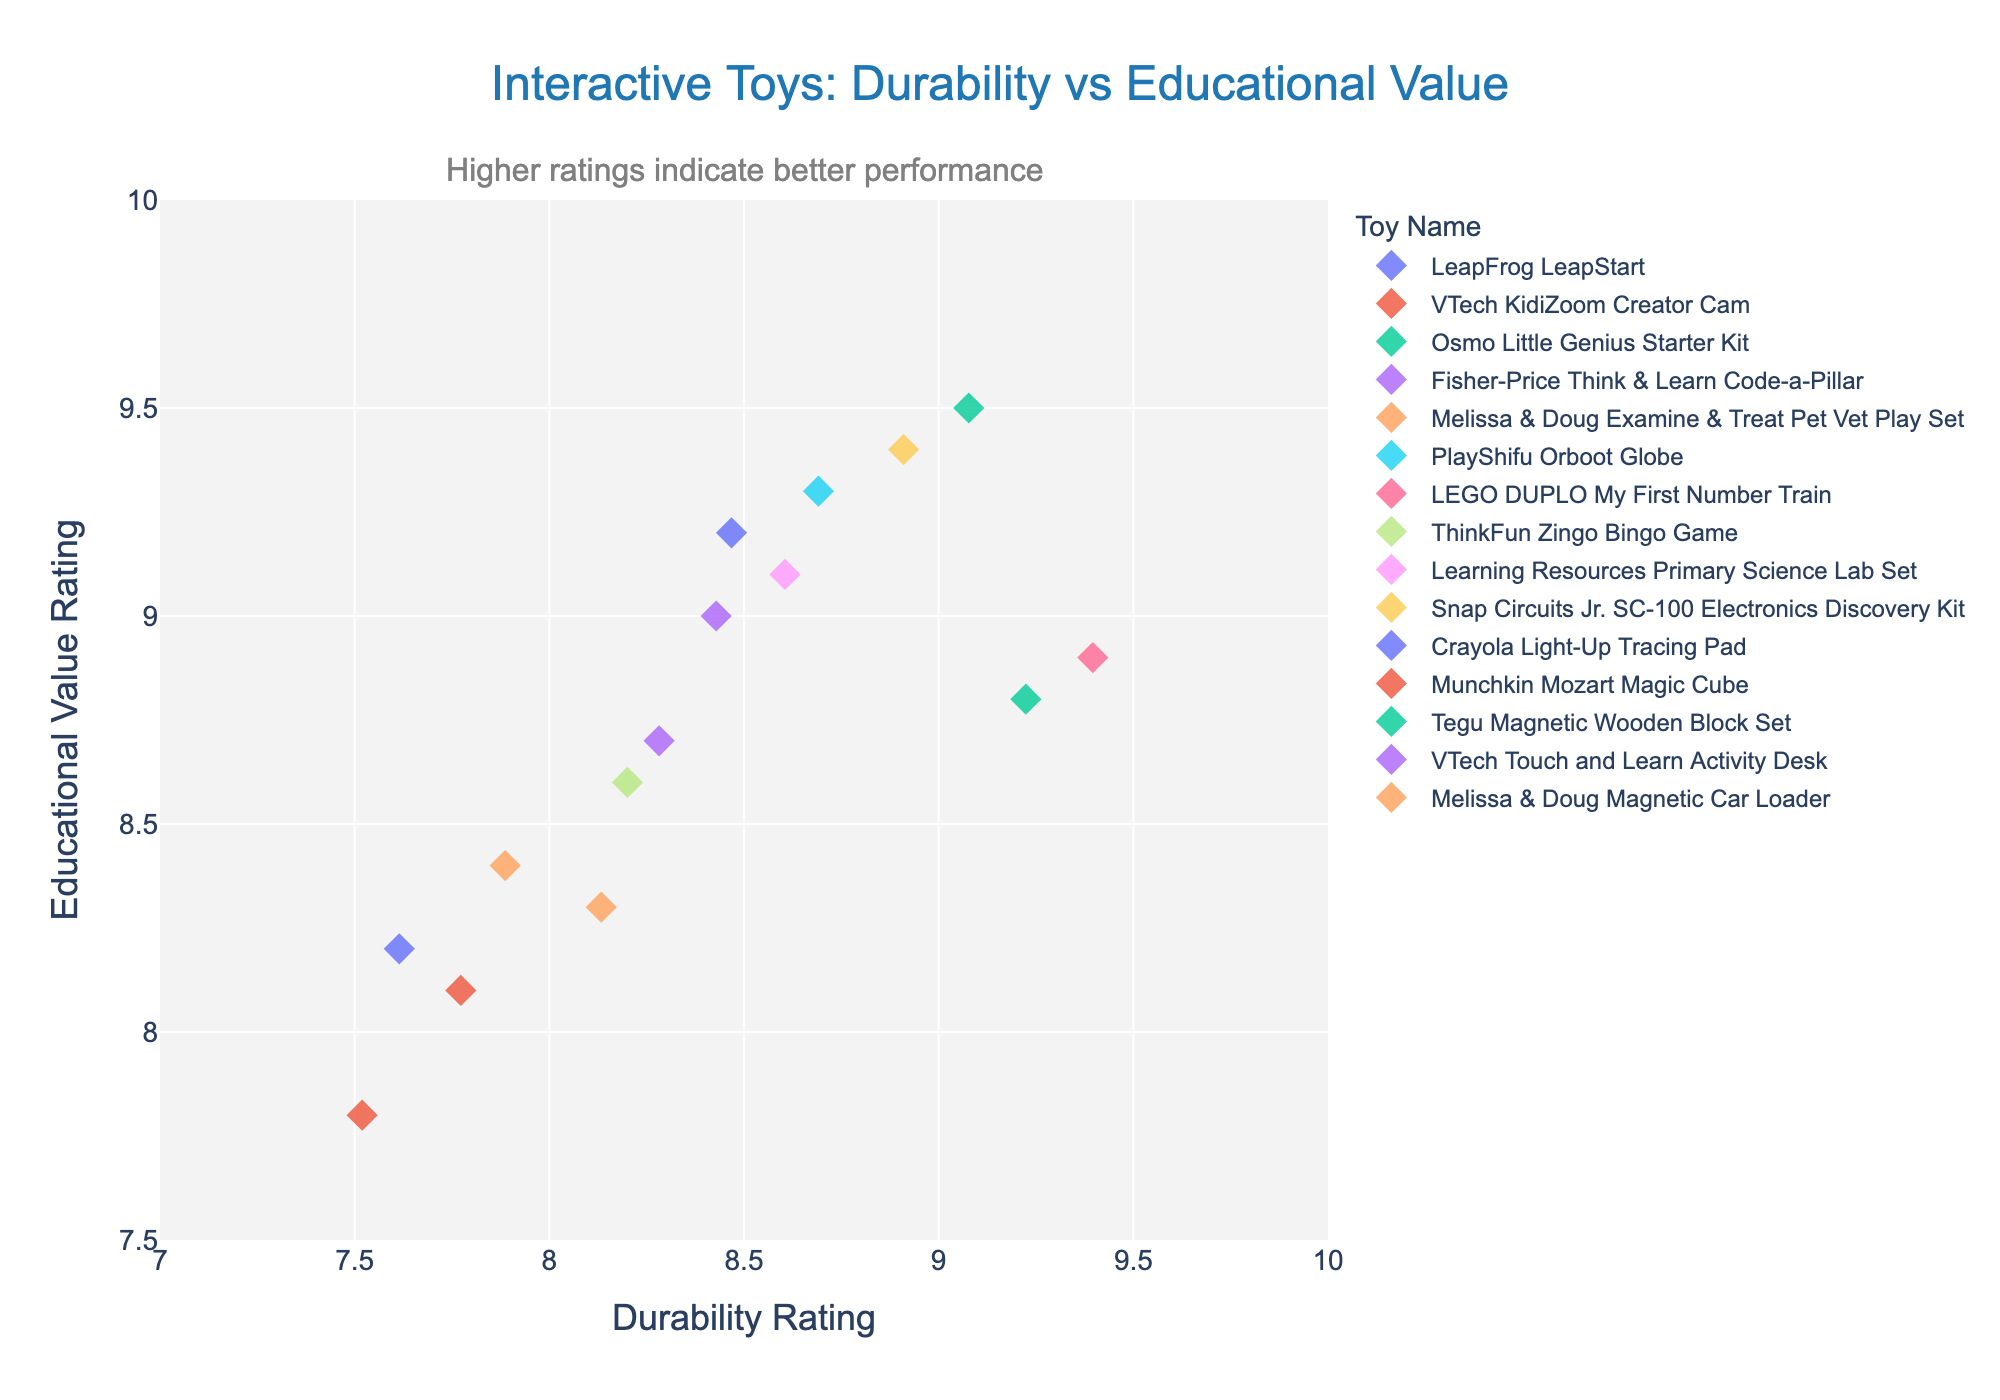What is the title of the plot? The title is displayed at the top of the plot in larger, bolded text, making it readily visible.
Answer: Interactive Toys: Durability vs Educational Value How many toys are shown in the plot? Each strip point corresponds to one toy, and there are markers with different colors, each representing a unique toy name. By counting these, we see there are 15 toys.
Answer: 15 Which toy has the highest durability rating? Look at the x-axis labeled "Durability Rating" and find the point farthest to the right. The toy at this point is "LEGO DUPLO My First Number Train" with a rating of 9.4.
Answer: LEGO DUPLO My First Number Train Which toy has the lowest educational value rating? Look at the y-axis labeled "Educational Value Rating" and find the point lowest on the axis. The toy at this point is "Munchkin Mozart Magic Cube" with a rating of 7.8.
Answer: Munchkin Mozart Magic Cube What is the durability rating range displayed on the x-axis? The x-axis starts at 7 and ends at 10, as shown by the axis range ticks.
Answer: 7 to 10 Which toys have an educational value rating greater than 9.0? Identify the points above the 9.0 mark on the y-axis. These toys are "LeapFrog LeapStart", "Osmo Little Genius Starter Kit", "PlayShifu Orboot Globe", "Learning Resources Primary Science Lab Set", "Snap Circuits Jr. SC-100 Electronics Discovery Kit", and "VTech Touch and Learn Activity Desk".
Answer: LeapFrog LeapStart, Osmo Little Genius Starter Kit, PlayShifu Orboot Globe, Learning Resources Primary Science Lab Set, Snap Circuits Jr. SC-100 Electronics Discovery Kit, VTech Touch and Learn Activity Desk What is the combined durability rating for "Crayola Light-Up Tracing Pad" and "Munchkin Mozart Magic Cube"? Locate the durability ratings for both toys (7.6 and 7.5) and add them together. 7.6 + 7.5 = 15.1
Answer: 15.1 What is the difference in educational value rating between "Fisher-Price Think & Learn Code-a-Pillar" and "Melissa & Doug Examine & Treat Pet Vet Play Set"? Locate the educational value ratings for both toys (8.7 and 8.4) and subtract one from the other. 8.7 - 8.4 = 0.3
Answer: 0.3 Which toy has the best balance between durability and educational value, meaning their ratings are closest? Look for the toy whose durability rating and educational value rating points are closest to each other on both axes. "Snap Circuits Jr. SC-100 Electronics Discovery Kit" has a durability rating of 8.9 and an educational value rating of 9.4, which are closest among all toys.
Answer: Snap Circuits Jr. SC-100 Electronics Discovery Kit 